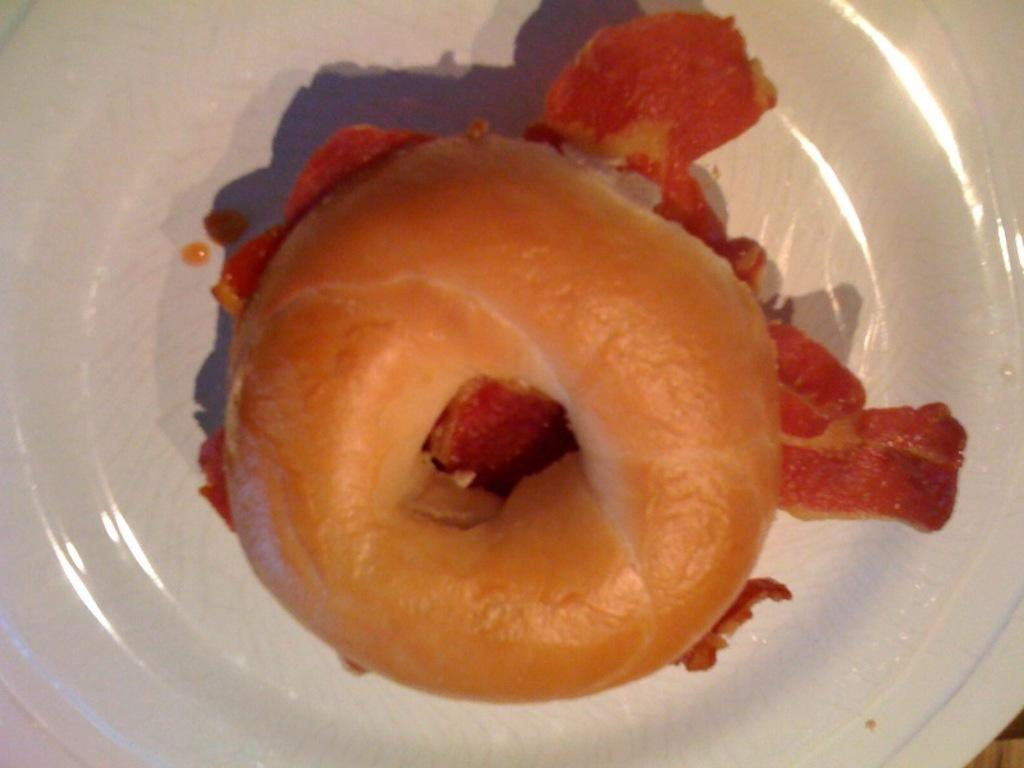What type of food is featured in the image? There is a meat-stuffed doughnut in the image. How is the meat-stuffed doughnut presented? The meat-stuffed doughnut is placed on a white ceramic plate. What type of flooring can be seen under the white ceramic plate in the image? The provided facts do not mention any flooring, so it cannot be determined from the image. 